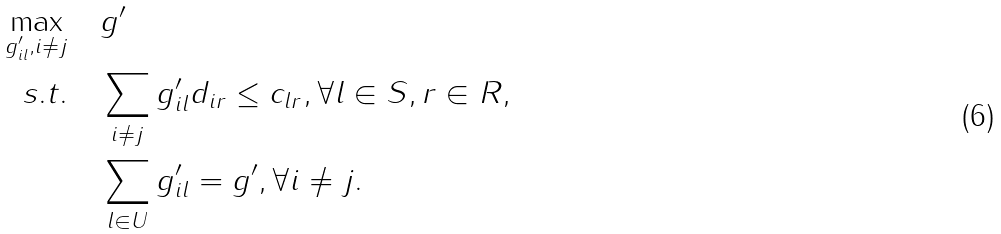Convert formula to latex. <formula><loc_0><loc_0><loc_500><loc_500>\max _ { g ^ { \prime } _ { i l } , i \neq j } & \quad g ^ { \prime } \\ s . t . & \quad \sum _ { i \neq j } g ^ { \prime } _ { i l } d _ { i r } \leq c _ { l r } , \forall l \in S , r \in R , \\ & \quad \sum _ { l \in U } g ^ { \prime } _ { i l } = g ^ { \prime } , \forall i \neq j .</formula> 